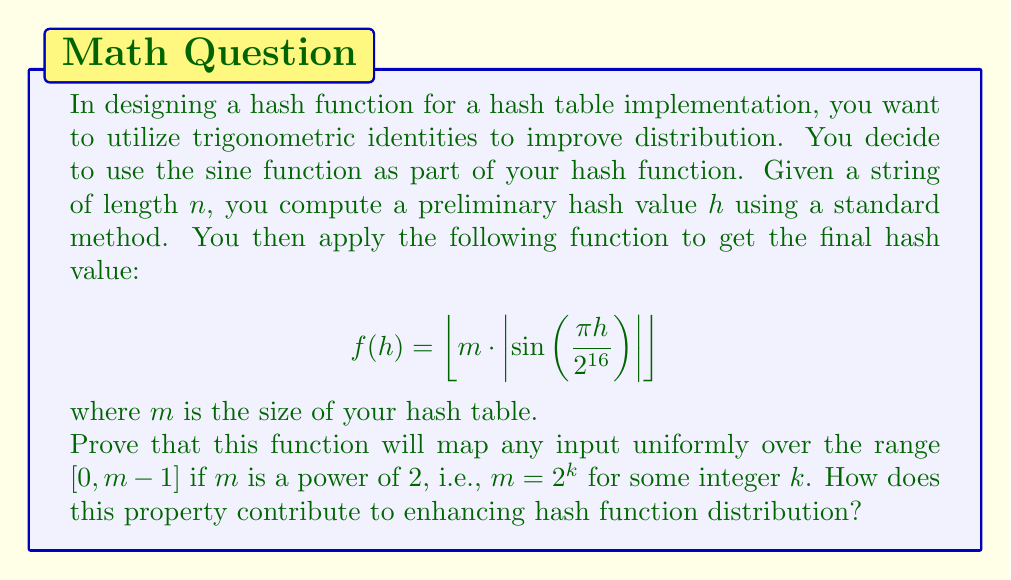Could you help me with this problem? To prove that this function maps any input uniformly over the range $[0, m-1]$ when $m$ is a power of 2, we need to consider the properties of the sine function and the given formula.

1. First, note that $\sin(x)$ has a period of $2\pi$. In our case, $\frac{\pi h}{2^{16}}$ will cycle through its full period when $h$ goes from 0 to $2^{17}$.

2. The absolute value function $|\sin(x)|$ has a period of $\pi$, which means it will cycle through its full range twice for every full cycle of $\sin(x)$.

3. $|\sin(x)|$ always produces values in the range $[0, 1]$.

4. When we multiply $|\sin(x)|$ by $m$, we're scaling this range to $[0, m]$.

5. The floor function $\lfloor \cdot \rfloor$ then maps these values to integers in the range $[0, m-1]$.

6. Now, because $m$ is a power of 2 ($m = 2^k$), we can write our function as:

   $$ f(h) = \left\lfloor 2^k \cdot \left|\sin\left(\frac{\pi h}{2^{16}}\right)\right| \right\rfloor $$

7. This is equivalent to taking the $k$ most significant bits of the binary representation of $|\sin(\frac{\pi h}{2^{16}})|$.

8. Due to the properties of the sine function, as $h$ varies, these $k$ most significant bits will cycle through all possible $k$-bit values uniformly.

This property contributes to enhancing hash function distribution in several ways:

a) It ensures that the hash values are spread uniformly across the entire range of the hash table, reducing clustering.

b) It helps to break up any patterns that might exist in the input data, as the sine function introduces a non-linear transformation.

c) The use of trigonometric functions makes it harder for an attacker to predict or manipulate hash values, enhancing security.

d) The uniform distribution helps maintain consistent performance regardless of the input data characteristics.
Answer: The function $f(h) = \left\lfloor m \cdot \left|\sin\left(\frac{\pi h}{2^{16}}\right)\right| \right\rfloor$ will map any input uniformly over the range $[0, m-1]$ when $m$ is a power of 2 due to the periodic and uniform properties of the sine function, combined with the scaling and flooring operations. This enhances hash function distribution by ensuring uniform spread, breaking input patterns, improving security, and maintaining consistent performance. 